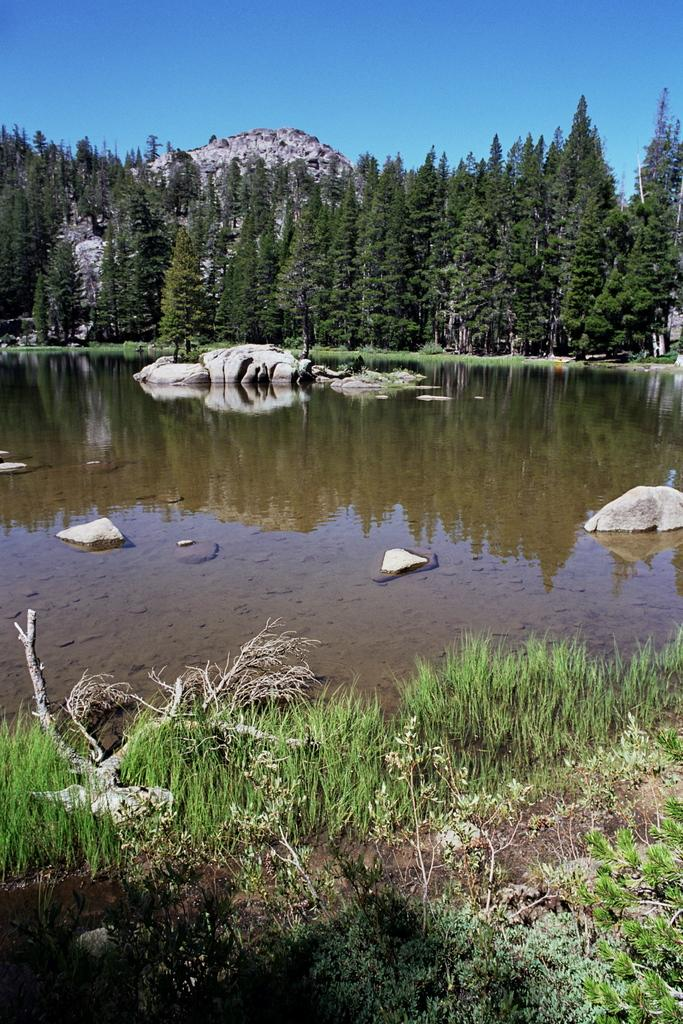What is one of the natural elements present in the image? There is water in the image. What type of vegetation can be seen in the image? There is grass, plants, and trees in the image. What geographical feature is visible in the image? There are hills in the image. Are there any objects floating on the water in the image? Yes, there are rocks on the water in the image. What type of pies are being baked in the image? There are no pies present in the image. What language is the book written in, and what is the title? There is no book present in the image. 